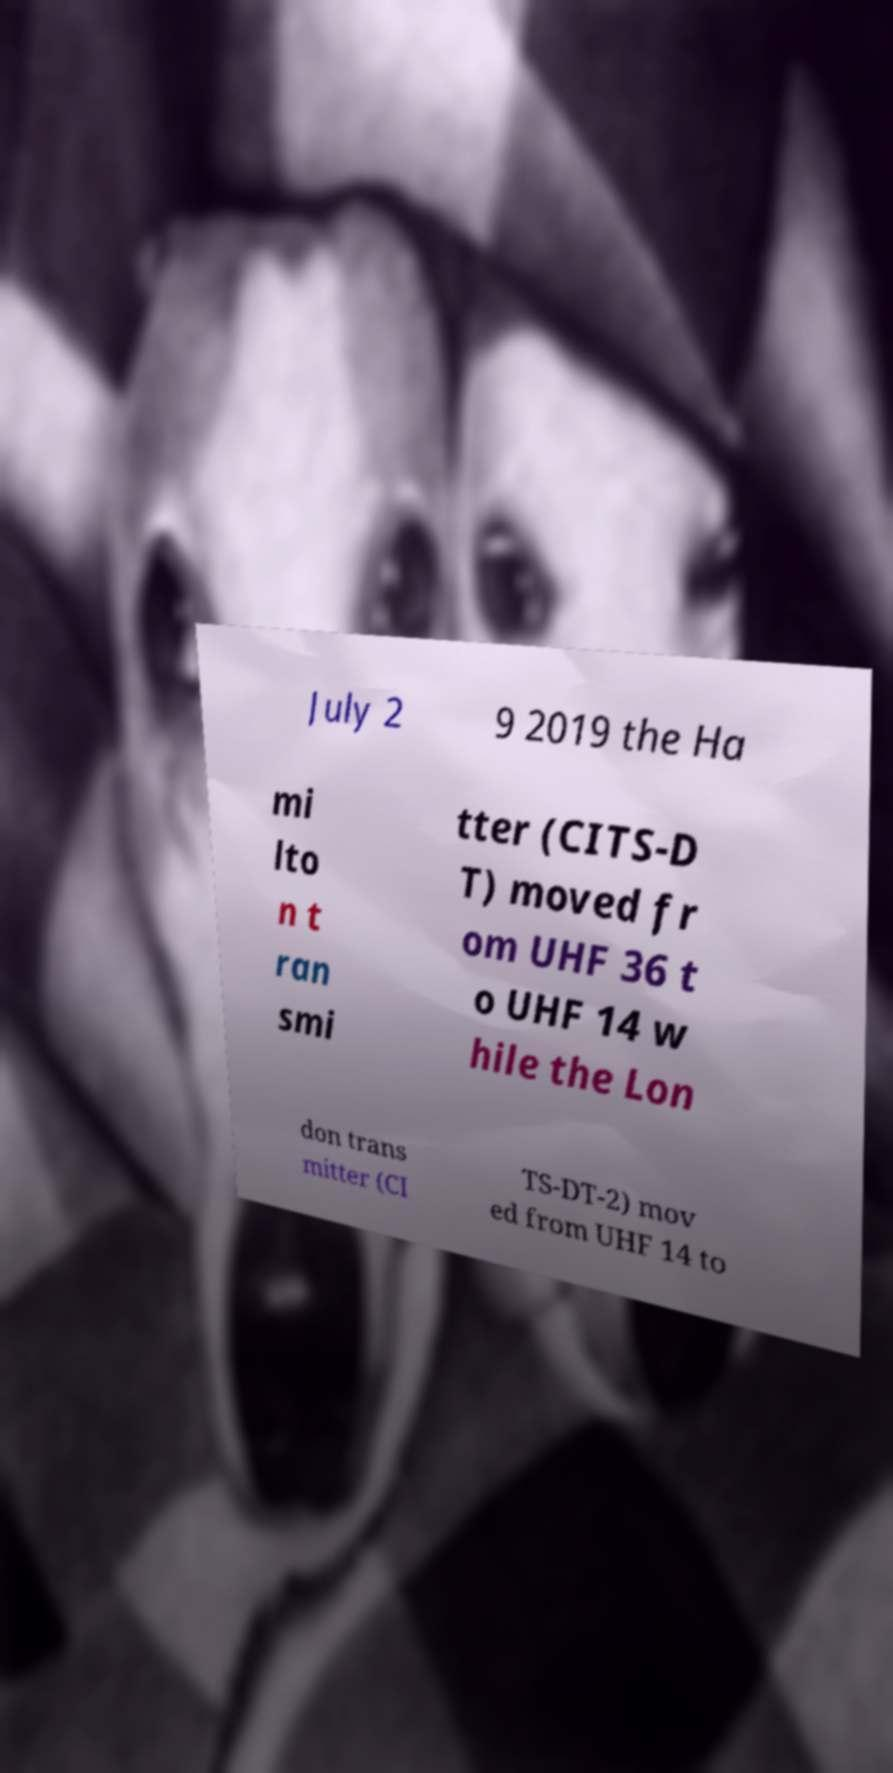There's text embedded in this image that I need extracted. Can you transcribe it verbatim? July 2 9 2019 the Ha mi lto n t ran smi tter (CITS-D T) moved fr om UHF 36 t o UHF 14 w hile the Lon don trans mitter (CI TS-DT-2) mov ed from UHF 14 to 